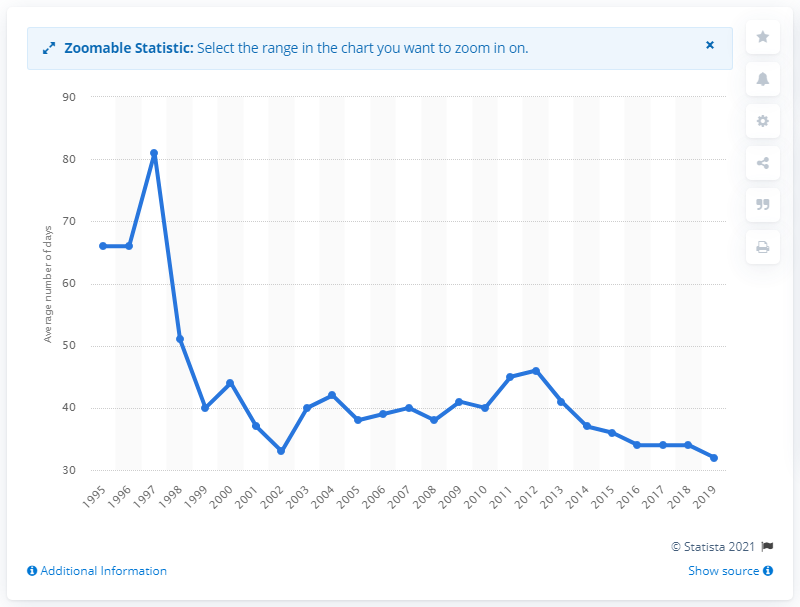Specify some key components in this picture. The average number of outages for nuclear power plants in the United States between 1995 and 2019 was 32 outages per year. In the year 1995, the average duration of power outages for nuclear power plants in the United States commenced. 